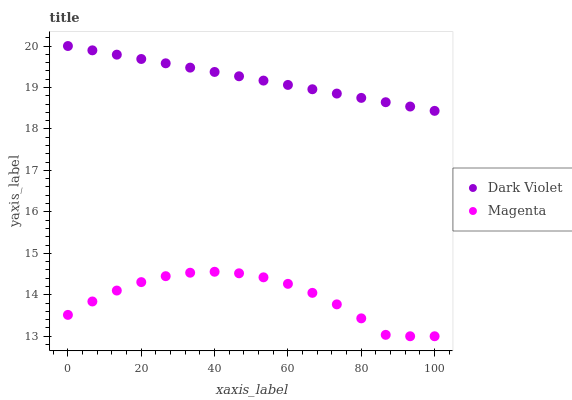Does Magenta have the minimum area under the curve?
Answer yes or no. Yes. Does Dark Violet have the maximum area under the curve?
Answer yes or no. Yes. Does Dark Violet have the minimum area under the curve?
Answer yes or no. No. Is Dark Violet the smoothest?
Answer yes or no. Yes. Is Magenta the roughest?
Answer yes or no. Yes. Is Dark Violet the roughest?
Answer yes or no. No. Does Magenta have the lowest value?
Answer yes or no. Yes. Does Dark Violet have the lowest value?
Answer yes or no. No. Does Dark Violet have the highest value?
Answer yes or no. Yes. Is Magenta less than Dark Violet?
Answer yes or no. Yes. Is Dark Violet greater than Magenta?
Answer yes or no. Yes. Does Magenta intersect Dark Violet?
Answer yes or no. No. 